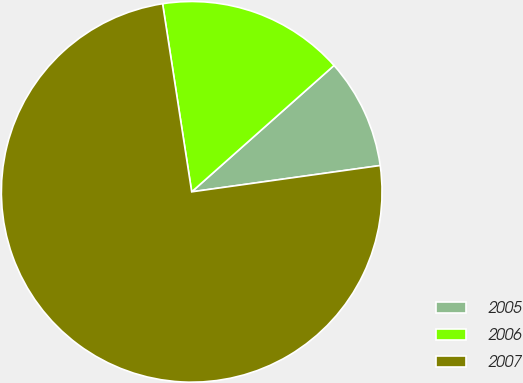Convert chart. <chart><loc_0><loc_0><loc_500><loc_500><pie_chart><fcel>2005<fcel>2006<fcel>2007<nl><fcel>9.35%<fcel>15.89%<fcel>74.77%<nl></chart> 